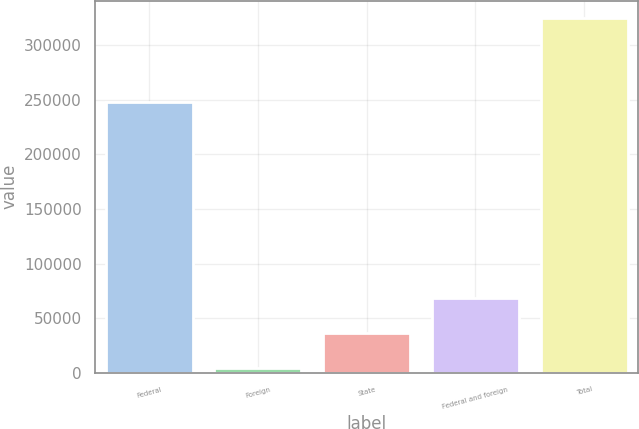Convert chart. <chart><loc_0><loc_0><loc_500><loc_500><bar_chart><fcel>Federal<fcel>Foreign<fcel>State<fcel>Federal and foreign<fcel>Total<nl><fcel>248172<fcel>4167<fcel>36217.4<fcel>68267.8<fcel>324671<nl></chart> 